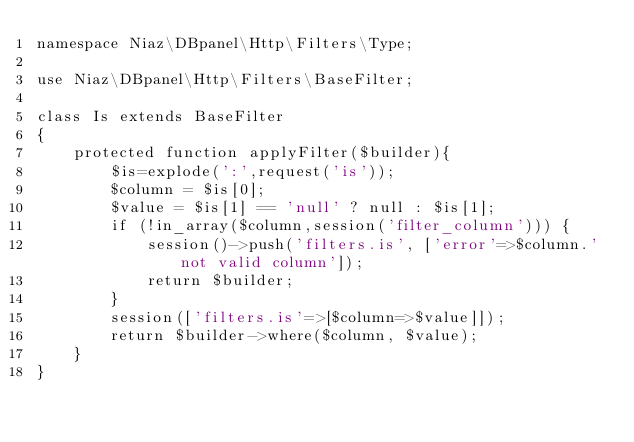<code> <loc_0><loc_0><loc_500><loc_500><_PHP_>namespace Niaz\DBpanel\Http\Filters\Type;

use Niaz\DBpanel\Http\Filters\BaseFilter;

class Is extends BaseFilter
{
    protected function applyFilter($builder){
        $is=explode(':',request('is'));
        $column = $is[0];
        $value = $is[1] == 'null' ? null : $is[1];
        if (!in_array($column,session('filter_column'))) {
            session()->push('filters.is', ['error'=>$column.' not valid column']);
            return $builder;
        }
        session(['filters.is'=>[$column=>$value]]);
        return $builder->where($column, $value);
    }
}</code> 